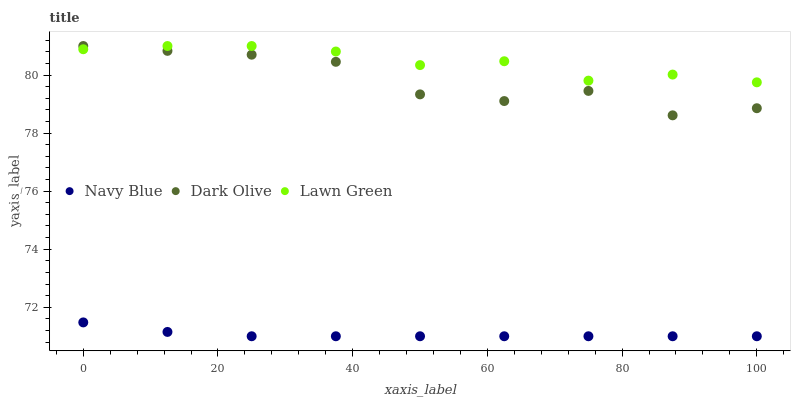Does Navy Blue have the minimum area under the curve?
Answer yes or no. Yes. Does Lawn Green have the maximum area under the curve?
Answer yes or no. Yes. Does Dark Olive have the minimum area under the curve?
Answer yes or no. No. Does Dark Olive have the maximum area under the curve?
Answer yes or no. No. Is Navy Blue the smoothest?
Answer yes or no. Yes. Is Dark Olive the roughest?
Answer yes or no. Yes. Is Lawn Green the smoothest?
Answer yes or no. No. Is Lawn Green the roughest?
Answer yes or no. No. Does Navy Blue have the lowest value?
Answer yes or no. Yes. Does Dark Olive have the lowest value?
Answer yes or no. No. Does Lawn Green have the highest value?
Answer yes or no. Yes. Is Navy Blue less than Dark Olive?
Answer yes or no. Yes. Is Dark Olive greater than Navy Blue?
Answer yes or no. Yes. Does Lawn Green intersect Dark Olive?
Answer yes or no. Yes. Is Lawn Green less than Dark Olive?
Answer yes or no. No. Is Lawn Green greater than Dark Olive?
Answer yes or no. No. Does Navy Blue intersect Dark Olive?
Answer yes or no. No. 